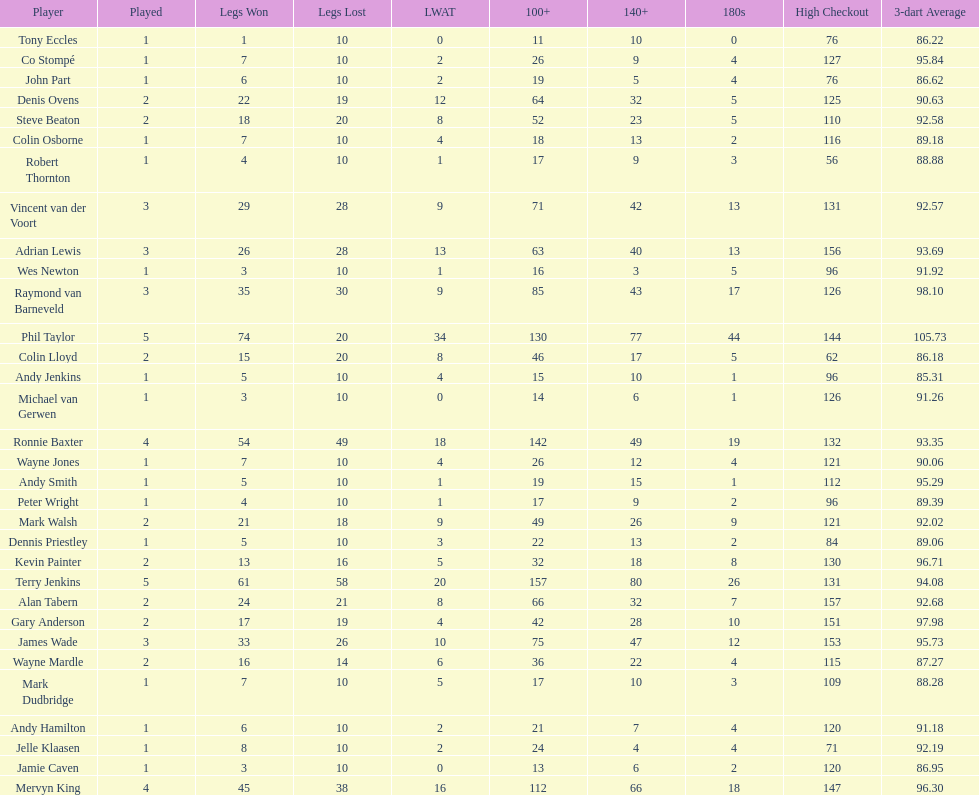What is the name of the next player after mark walsh? Wes Newton. Help me parse the entirety of this table. {'header': ['Player', 'Played', 'Legs Won', 'Legs Lost', 'LWAT', '100+', '140+', '180s', 'High Checkout', '3-dart Average'], 'rows': [['Tony Eccles', '1', '1', '10', '0', '11', '10', '0', '76', '86.22'], ['Co Stompé', '1', '7', '10', '2', '26', '9', '4', '127', '95.84'], ['John Part', '1', '6', '10', '2', '19', '5', '4', '76', '86.62'], ['Denis Ovens', '2', '22', '19', '12', '64', '32', '5', '125', '90.63'], ['Steve Beaton', '2', '18', '20', '8', '52', '23', '5', '110', '92.58'], ['Colin Osborne', '1', '7', '10', '4', '18', '13', '2', '116', '89.18'], ['Robert Thornton', '1', '4', '10', '1', '17', '9', '3', '56', '88.88'], ['Vincent van der Voort', '3', '29', '28', '9', '71', '42', '13', '131', '92.57'], ['Adrian Lewis', '3', '26', '28', '13', '63', '40', '13', '156', '93.69'], ['Wes Newton', '1', '3', '10', '1', '16', '3', '5', '96', '91.92'], ['Raymond van Barneveld', '3', '35', '30', '9', '85', '43', '17', '126', '98.10'], ['Phil Taylor', '5', '74', '20', '34', '130', '77', '44', '144', '105.73'], ['Colin Lloyd', '2', '15', '20', '8', '46', '17', '5', '62', '86.18'], ['Andy Jenkins', '1', '5', '10', '4', '15', '10', '1', '96', '85.31'], ['Michael van Gerwen', '1', '3', '10', '0', '14', '6', '1', '126', '91.26'], ['Ronnie Baxter', '4', '54', '49', '18', '142', '49', '19', '132', '93.35'], ['Wayne Jones', '1', '7', '10', '4', '26', '12', '4', '121', '90.06'], ['Andy Smith', '1', '5', '10', '1', '19', '15', '1', '112', '95.29'], ['Peter Wright', '1', '4', '10', '1', '17', '9', '2', '96', '89.39'], ['Mark Walsh', '2', '21', '18', '9', '49', '26', '9', '121', '92.02'], ['Dennis Priestley', '1', '5', '10', '3', '22', '13', '2', '84', '89.06'], ['Kevin Painter', '2', '13', '16', '5', '32', '18', '8', '130', '96.71'], ['Terry Jenkins', '5', '61', '58', '20', '157', '80', '26', '131', '94.08'], ['Alan Tabern', '2', '24', '21', '8', '66', '32', '7', '157', '92.68'], ['Gary Anderson', '2', '17', '19', '4', '42', '28', '10', '151', '97.98'], ['James Wade', '3', '33', '26', '10', '75', '47', '12', '153', '95.73'], ['Wayne Mardle', '2', '16', '14', '6', '36', '22', '4', '115', '87.27'], ['Mark Dudbridge', '1', '7', '10', '5', '17', '10', '3', '109', '88.28'], ['Andy Hamilton', '1', '6', '10', '2', '21', '7', '4', '120', '91.18'], ['Jelle Klaasen', '1', '8', '10', '2', '24', '4', '4', '71', '92.19'], ['Jamie Caven', '1', '3', '10', '0', '13', '6', '2', '120', '86.95'], ['Mervyn King', '4', '45', '38', '16', '112', '66', '18', '147', '96.30']]} 